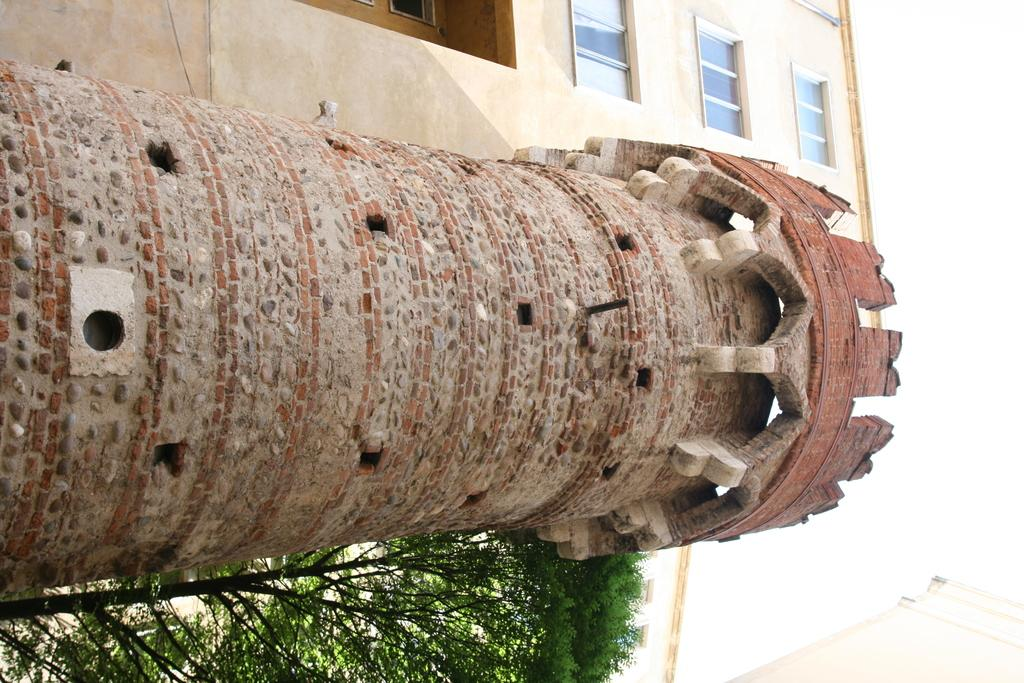What is the main subject in the center of the image? There is a tower in the center of the image. What can be seen in the background of the image? There are buildings and trees in the background of the image. How many geese are flying over the tower in the image? There are no geese visible in the image. 